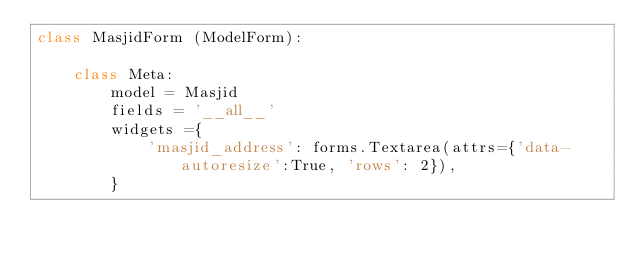Convert code to text. <code><loc_0><loc_0><loc_500><loc_500><_Python_>class MasjidForm (ModelForm):

    class Meta:
        model = Masjid
        fields = '__all__'
        widgets ={
            'masjid_address': forms.Textarea(attrs={'data-autoresize':True, 'rows': 2}),
        }

   
</code> 